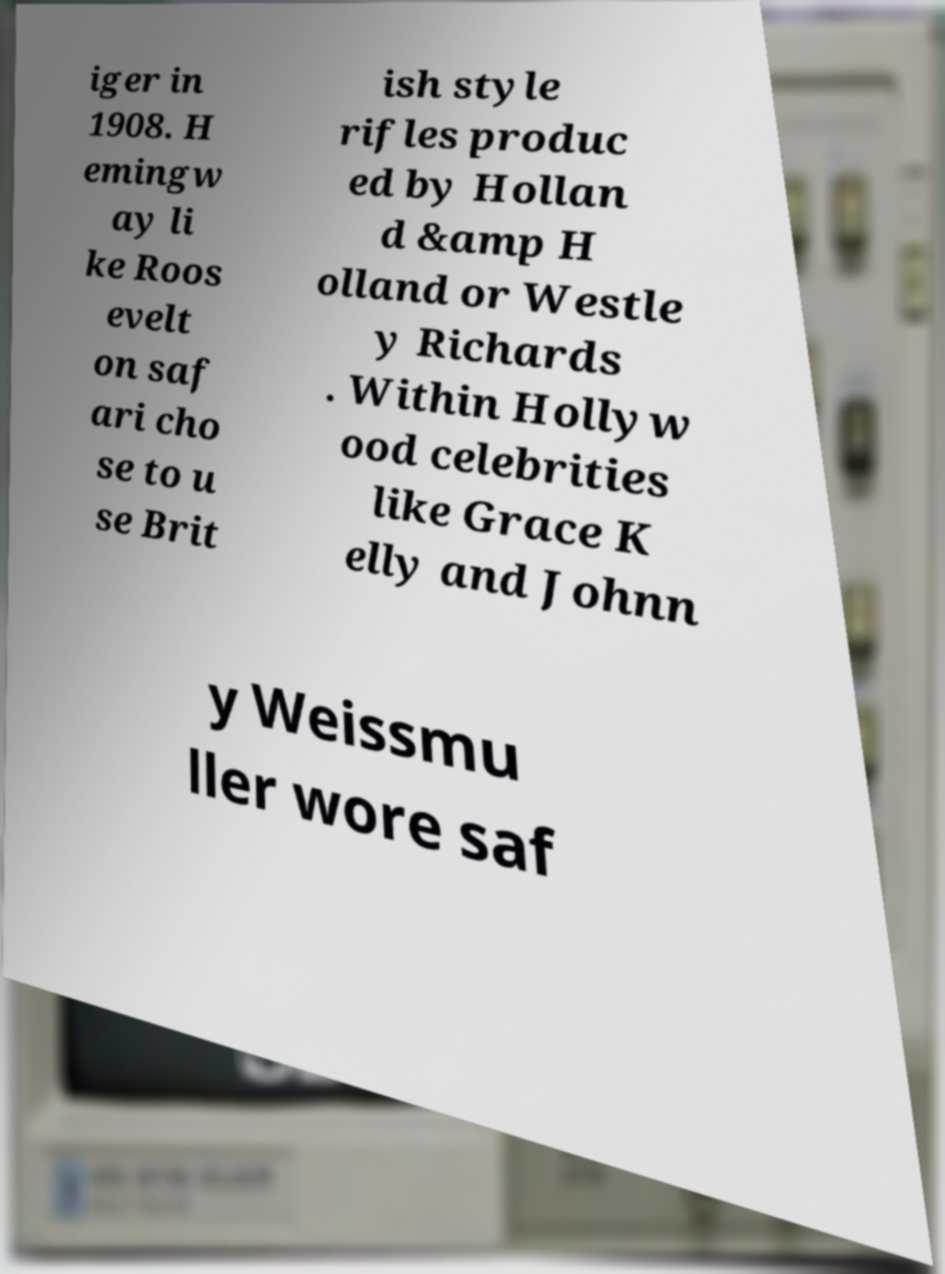Could you assist in decoding the text presented in this image and type it out clearly? iger in 1908. H emingw ay li ke Roos evelt on saf ari cho se to u se Brit ish style rifles produc ed by Hollan d &amp H olland or Westle y Richards . Within Hollyw ood celebrities like Grace K elly and Johnn y Weissmu ller wore saf 